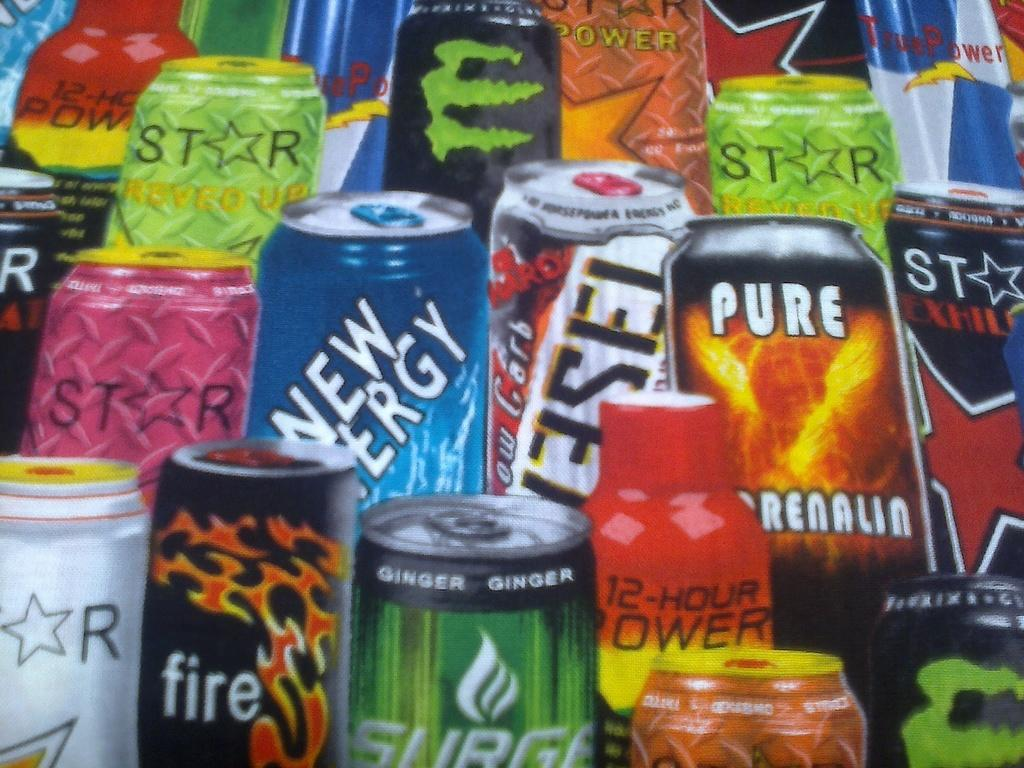Provide a one-sentence caption for the provided image. A poster shows many different cans of energy drinks, including STAR, FIRE, and PURE. 